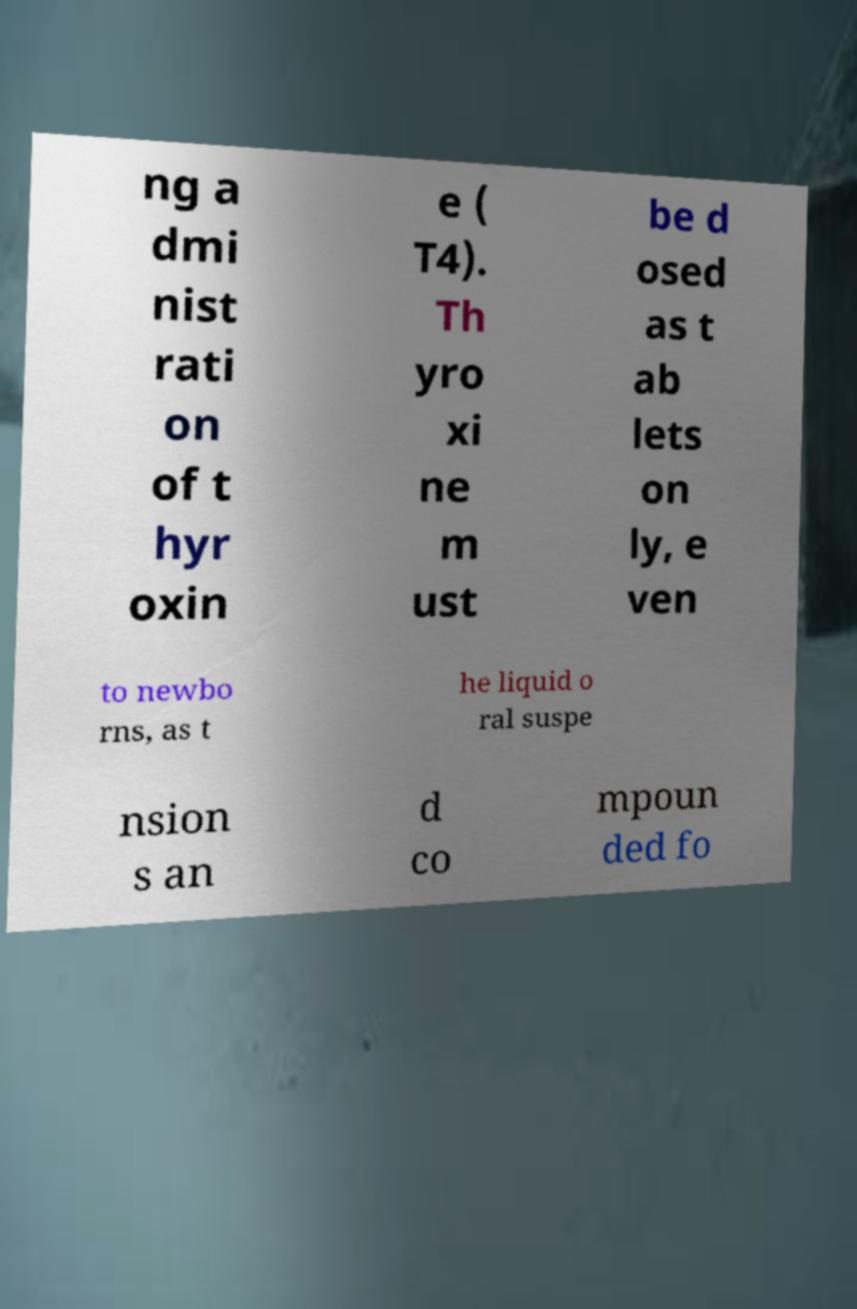Can you read and provide the text displayed in the image?This photo seems to have some interesting text. Can you extract and type it out for me? ng a dmi nist rati on of t hyr oxin e ( T4). Th yro xi ne m ust be d osed as t ab lets on ly, e ven to newbo rns, as t he liquid o ral suspe nsion s an d co mpoun ded fo 